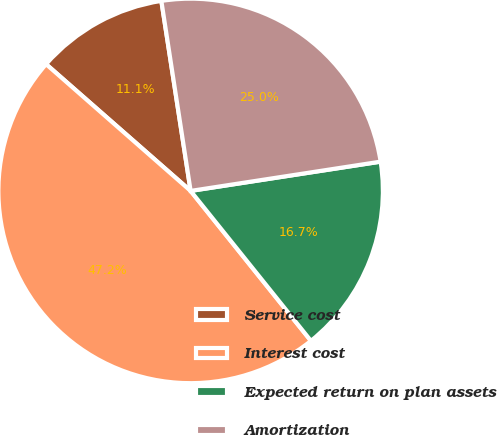<chart> <loc_0><loc_0><loc_500><loc_500><pie_chart><fcel>Service cost<fcel>Interest cost<fcel>Expected return on plan assets<fcel>Amortization<nl><fcel>11.11%<fcel>47.22%<fcel>16.67%<fcel>25.0%<nl></chart> 